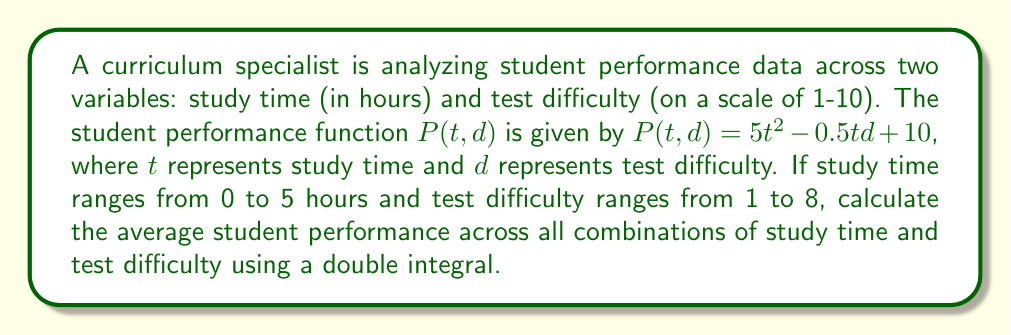Give your solution to this math problem. To solve this problem, we need to follow these steps:

1) The average value of a function $f(x,y)$ over a region $R$ is given by:

   $$ \text{Average} = \frac{\iint_R f(x,y) \, dA}{\text{Area of R}} $$

2) In our case, $f(t,d) = P(t,d) = 5t^2 - 0.5td + 10$, and the region $R$ is defined by $0 \leq t \leq 5$ and $1 \leq d \leq 8$.

3) Set up the double integral:

   $$ \text{Average} = \frac{\int_1^8 \int_0^5 (5t^2 - 0.5td + 10) \, dt \, dd}{(5-0)(8-1)} $$

4) Integrate with respect to $t$ first:

   $$ \int_0^5 (5t^2 - 0.5td + 10) \, dt = [\frac{5t^3}{3} - \frac{0.25td^2}{2} + 10t]_0^5 $$
   $$ = (\frac{625}{3} - \frac{25d}{4} + 50) - (0) = \frac{625}{3} - \frac{25d}{4} + 50 $$

5) Now integrate with respect to $d$:

   $$ \int_1^8 (\frac{625}{3} - \frac{25d}{4} + 50) \, dd = [\frac{625d}{3} - \frac{25d^2}{8} + 50d]_1^8 $$
   $$ = (\frac{5000}{3} - 200 + 400) - (\frac{625}{3} - \frac{25}{8} + 50) $$
   $$ = \frac{13075}{3} - \frac{575}{8} $$

6) Divide by the area of the region:

   $$ \text{Average} = \frac{\frac{13075}{3} - \frac{575}{8}}{(5-0)(8-1)} = \frac{\frac{13075}{3} - \frac{575}{8}}{35} $$

7) Simplify:

   $$ \text{Average} = \frac{104600 - 2300}{840} = \frac{102300}{840} = 121.7857... $$
Answer: $\frac{102300}{840} \approx 121.79$ 